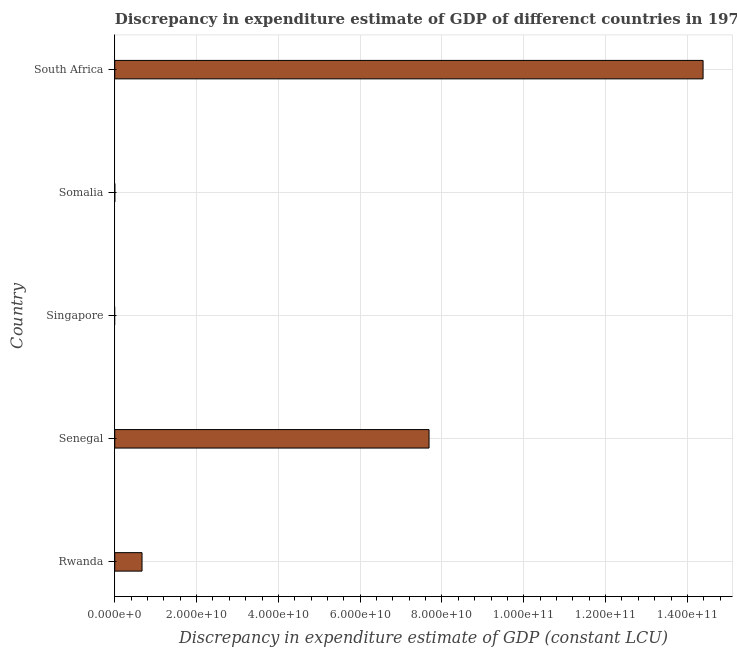Does the graph contain grids?
Make the answer very short. Yes. What is the title of the graph?
Keep it short and to the point. Discrepancy in expenditure estimate of GDP of differenct countries in 1979. What is the label or title of the X-axis?
Your answer should be compact. Discrepancy in expenditure estimate of GDP (constant LCU). What is the discrepancy in expenditure estimate of gdp in Senegal?
Make the answer very short. 7.68e+1. Across all countries, what is the maximum discrepancy in expenditure estimate of gdp?
Provide a succinct answer. 1.44e+11. In which country was the discrepancy in expenditure estimate of gdp maximum?
Your response must be concise. South Africa. What is the sum of the discrepancy in expenditure estimate of gdp?
Provide a succinct answer. 2.27e+11. What is the difference between the discrepancy in expenditure estimate of gdp in Rwanda and South Africa?
Offer a very short reply. -1.37e+11. What is the average discrepancy in expenditure estimate of gdp per country?
Your response must be concise. 4.55e+1. What is the median discrepancy in expenditure estimate of gdp?
Give a very brief answer. 6.67e+09. What is the ratio of the discrepancy in expenditure estimate of gdp in Senegal to that in South Africa?
Give a very brief answer. 0.53. Is the discrepancy in expenditure estimate of gdp in Somalia less than that in South Africa?
Provide a succinct answer. Yes. What is the difference between the highest and the second highest discrepancy in expenditure estimate of gdp?
Your response must be concise. 6.70e+1. What is the difference between the highest and the lowest discrepancy in expenditure estimate of gdp?
Your response must be concise. 1.44e+11. In how many countries, is the discrepancy in expenditure estimate of gdp greater than the average discrepancy in expenditure estimate of gdp taken over all countries?
Provide a succinct answer. 2. Are all the bars in the graph horizontal?
Ensure brevity in your answer.  Yes. Are the values on the major ticks of X-axis written in scientific E-notation?
Provide a succinct answer. Yes. What is the Discrepancy in expenditure estimate of GDP (constant LCU) of Rwanda?
Offer a terse response. 6.67e+09. What is the Discrepancy in expenditure estimate of GDP (constant LCU) of Senegal?
Make the answer very short. 7.68e+1. What is the Discrepancy in expenditure estimate of GDP (constant LCU) in Singapore?
Make the answer very short. 0. What is the Discrepancy in expenditure estimate of GDP (constant LCU) in Somalia?
Make the answer very short. 1.01e+06. What is the Discrepancy in expenditure estimate of GDP (constant LCU) in South Africa?
Your answer should be compact. 1.44e+11. What is the difference between the Discrepancy in expenditure estimate of GDP (constant LCU) in Rwanda and Senegal?
Make the answer very short. -7.02e+1. What is the difference between the Discrepancy in expenditure estimate of GDP (constant LCU) in Rwanda and Somalia?
Provide a short and direct response. 6.67e+09. What is the difference between the Discrepancy in expenditure estimate of GDP (constant LCU) in Rwanda and South Africa?
Ensure brevity in your answer.  -1.37e+11. What is the difference between the Discrepancy in expenditure estimate of GDP (constant LCU) in Senegal and Somalia?
Offer a terse response. 7.68e+1. What is the difference between the Discrepancy in expenditure estimate of GDP (constant LCU) in Senegal and South Africa?
Give a very brief answer. -6.70e+1. What is the difference between the Discrepancy in expenditure estimate of GDP (constant LCU) in Somalia and South Africa?
Your answer should be compact. -1.44e+11. What is the ratio of the Discrepancy in expenditure estimate of GDP (constant LCU) in Rwanda to that in Senegal?
Give a very brief answer. 0.09. What is the ratio of the Discrepancy in expenditure estimate of GDP (constant LCU) in Rwanda to that in Somalia?
Provide a short and direct response. 6600.56. What is the ratio of the Discrepancy in expenditure estimate of GDP (constant LCU) in Rwanda to that in South Africa?
Give a very brief answer. 0.05. What is the ratio of the Discrepancy in expenditure estimate of GDP (constant LCU) in Senegal to that in Somalia?
Your response must be concise. 7.61e+04. What is the ratio of the Discrepancy in expenditure estimate of GDP (constant LCU) in Senegal to that in South Africa?
Give a very brief answer. 0.53. What is the ratio of the Discrepancy in expenditure estimate of GDP (constant LCU) in Somalia to that in South Africa?
Offer a terse response. 0. 